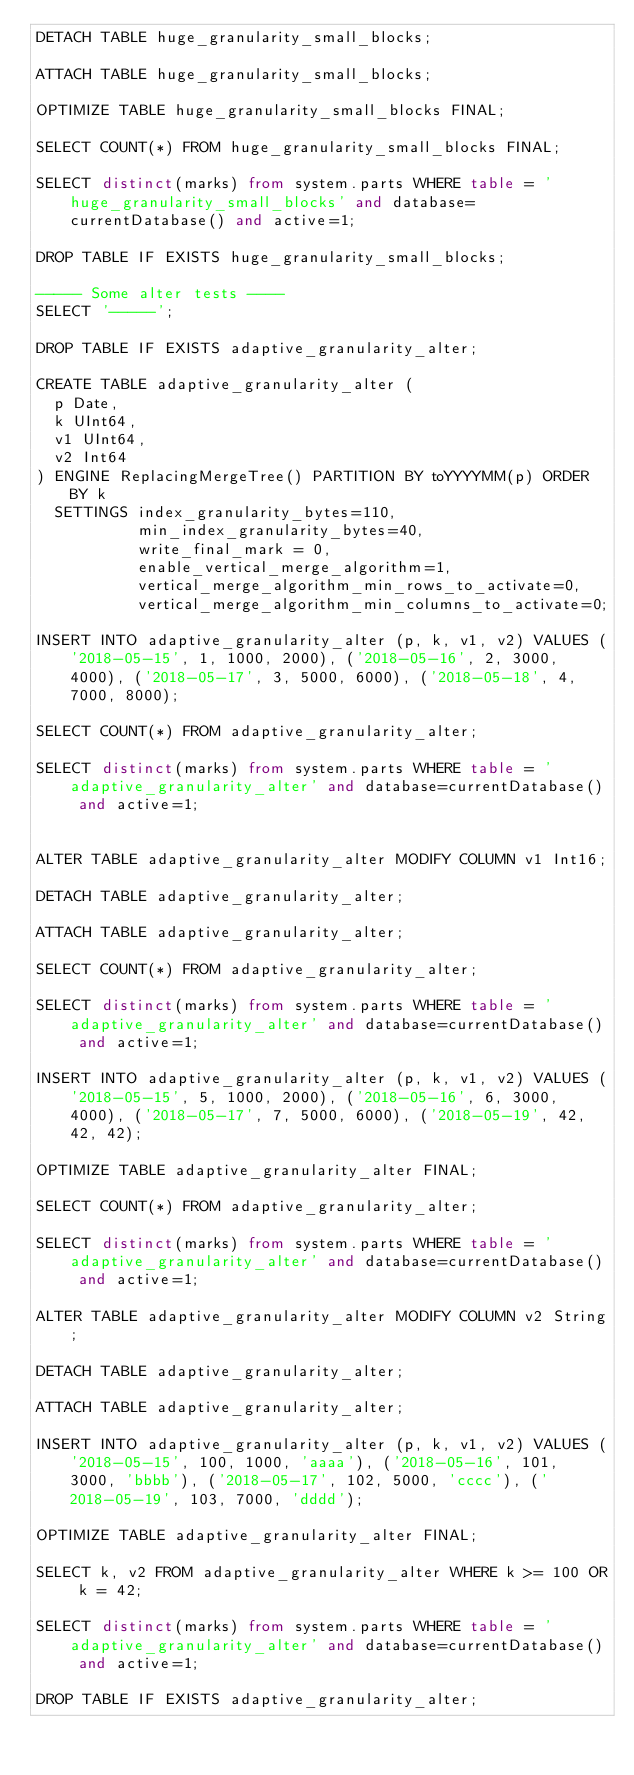<code> <loc_0><loc_0><loc_500><loc_500><_SQL_>DETACH TABLE huge_granularity_small_blocks;

ATTACH TABLE huge_granularity_small_blocks;

OPTIMIZE TABLE huge_granularity_small_blocks FINAL;

SELECT COUNT(*) FROM huge_granularity_small_blocks FINAL;

SELECT distinct(marks) from system.parts WHERE table = 'huge_granularity_small_blocks' and database=currentDatabase() and active=1;

DROP TABLE IF EXISTS huge_granularity_small_blocks;

----- Some alter tests ----
SELECT '-----';

DROP TABLE IF EXISTS adaptive_granularity_alter;

CREATE TABLE adaptive_granularity_alter (
  p Date,
  k UInt64,
  v1 UInt64,
  v2 Int64
) ENGINE ReplacingMergeTree() PARTITION BY toYYYYMM(p) ORDER BY k
  SETTINGS index_granularity_bytes=110,
           min_index_granularity_bytes=40,
           write_final_mark = 0,
           enable_vertical_merge_algorithm=1,
           vertical_merge_algorithm_min_rows_to_activate=0,
           vertical_merge_algorithm_min_columns_to_activate=0;

INSERT INTO adaptive_granularity_alter (p, k, v1, v2) VALUES ('2018-05-15', 1, 1000, 2000), ('2018-05-16', 2, 3000, 4000), ('2018-05-17', 3, 5000, 6000), ('2018-05-18', 4, 7000, 8000);

SELECT COUNT(*) FROM adaptive_granularity_alter;

SELECT distinct(marks) from system.parts WHERE table = 'adaptive_granularity_alter' and database=currentDatabase() and active=1;


ALTER TABLE adaptive_granularity_alter MODIFY COLUMN v1 Int16;

DETACH TABLE adaptive_granularity_alter;

ATTACH TABLE adaptive_granularity_alter;

SELECT COUNT(*) FROM adaptive_granularity_alter;

SELECT distinct(marks) from system.parts WHERE table = 'adaptive_granularity_alter' and database=currentDatabase() and active=1;

INSERT INTO adaptive_granularity_alter (p, k, v1, v2) VALUES ('2018-05-15', 5, 1000, 2000), ('2018-05-16', 6, 3000, 4000), ('2018-05-17', 7, 5000, 6000), ('2018-05-19', 42, 42, 42);

OPTIMIZE TABLE adaptive_granularity_alter FINAL;

SELECT COUNT(*) FROM adaptive_granularity_alter;

SELECT distinct(marks) from system.parts WHERE table = 'adaptive_granularity_alter' and database=currentDatabase() and active=1;

ALTER TABLE adaptive_granularity_alter MODIFY COLUMN v2 String;

DETACH TABLE adaptive_granularity_alter;

ATTACH TABLE adaptive_granularity_alter;

INSERT INTO adaptive_granularity_alter (p, k, v1, v2) VALUES ('2018-05-15', 100, 1000, 'aaaa'), ('2018-05-16', 101, 3000, 'bbbb'), ('2018-05-17', 102, 5000, 'cccc'), ('2018-05-19', 103, 7000, 'dddd');

OPTIMIZE TABLE adaptive_granularity_alter FINAL;

SELECT k, v2 FROM adaptive_granularity_alter WHERE k >= 100 OR k = 42;

SELECT distinct(marks) from system.parts WHERE table = 'adaptive_granularity_alter' and database=currentDatabase() and active=1;

DROP TABLE IF EXISTS adaptive_granularity_alter;
</code> 